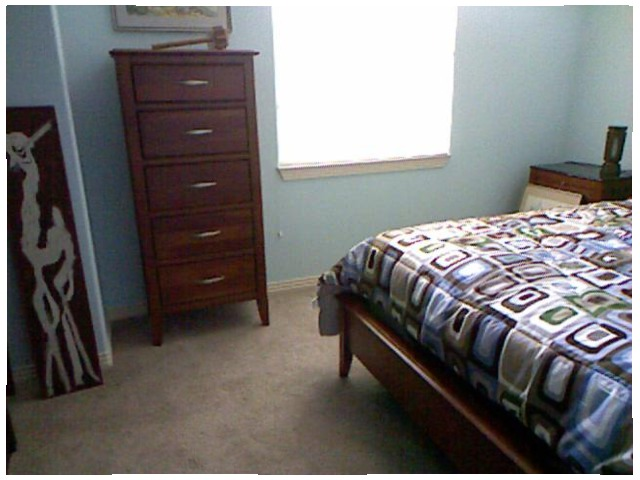<image>
Is the dresser on the floor? Yes. Looking at the image, I can see the dresser is positioned on top of the floor, with the floor providing support. Is the picture on the wall? No. The picture is not positioned on the wall. They may be near each other, but the picture is not supported by or resting on top of the wall. Is the picture to the left of the bed? Yes. From this viewpoint, the picture is positioned to the left side relative to the bed. 